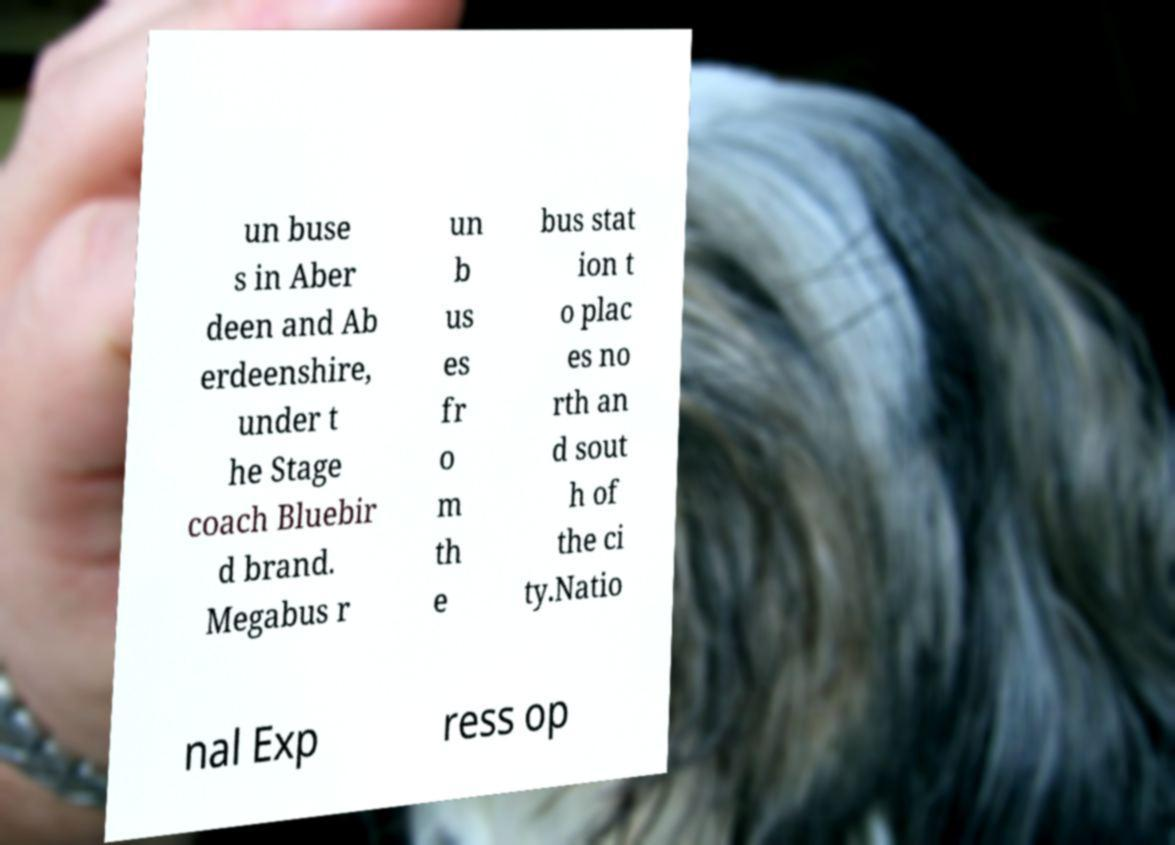There's text embedded in this image that I need extracted. Can you transcribe it verbatim? un buse s in Aber deen and Ab erdeenshire, under t he Stage coach Bluebir d brand. Megabus r un b us es fr o m th e bus stat ion t o plac es no rth an d sout h of the ci ty.Natio nal Exp ress op 